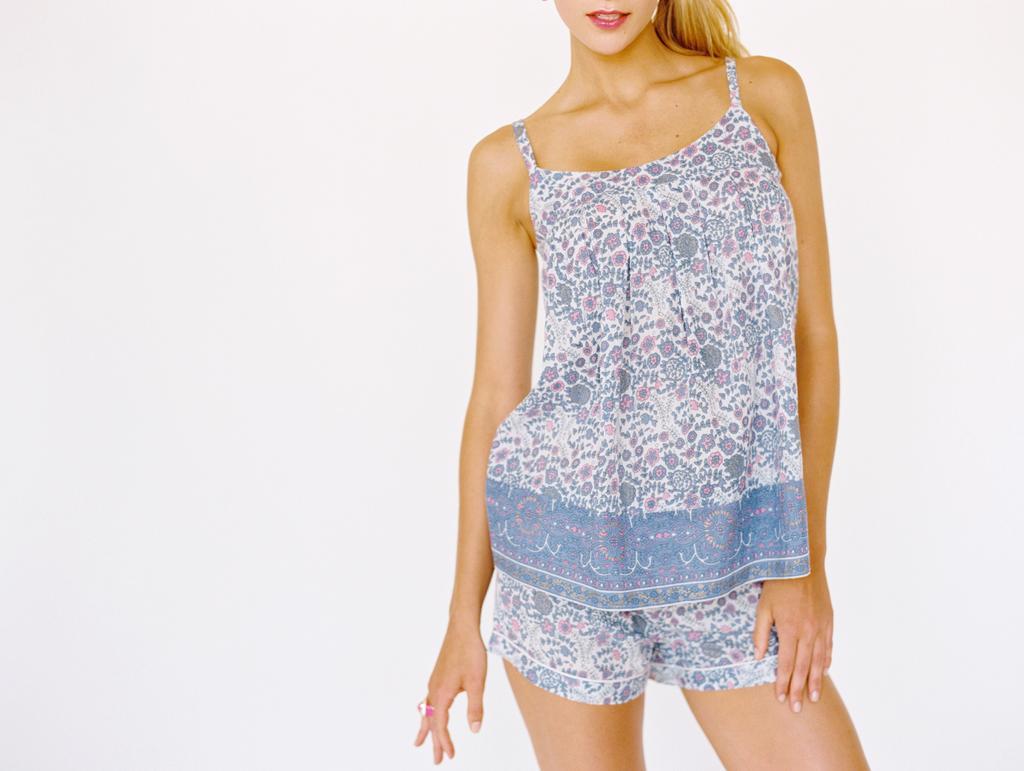Please provide a concise description of this image. In this picture I can see a woman standing in front and I see that she is wearing white and blue color dress and I can see the white color background. 